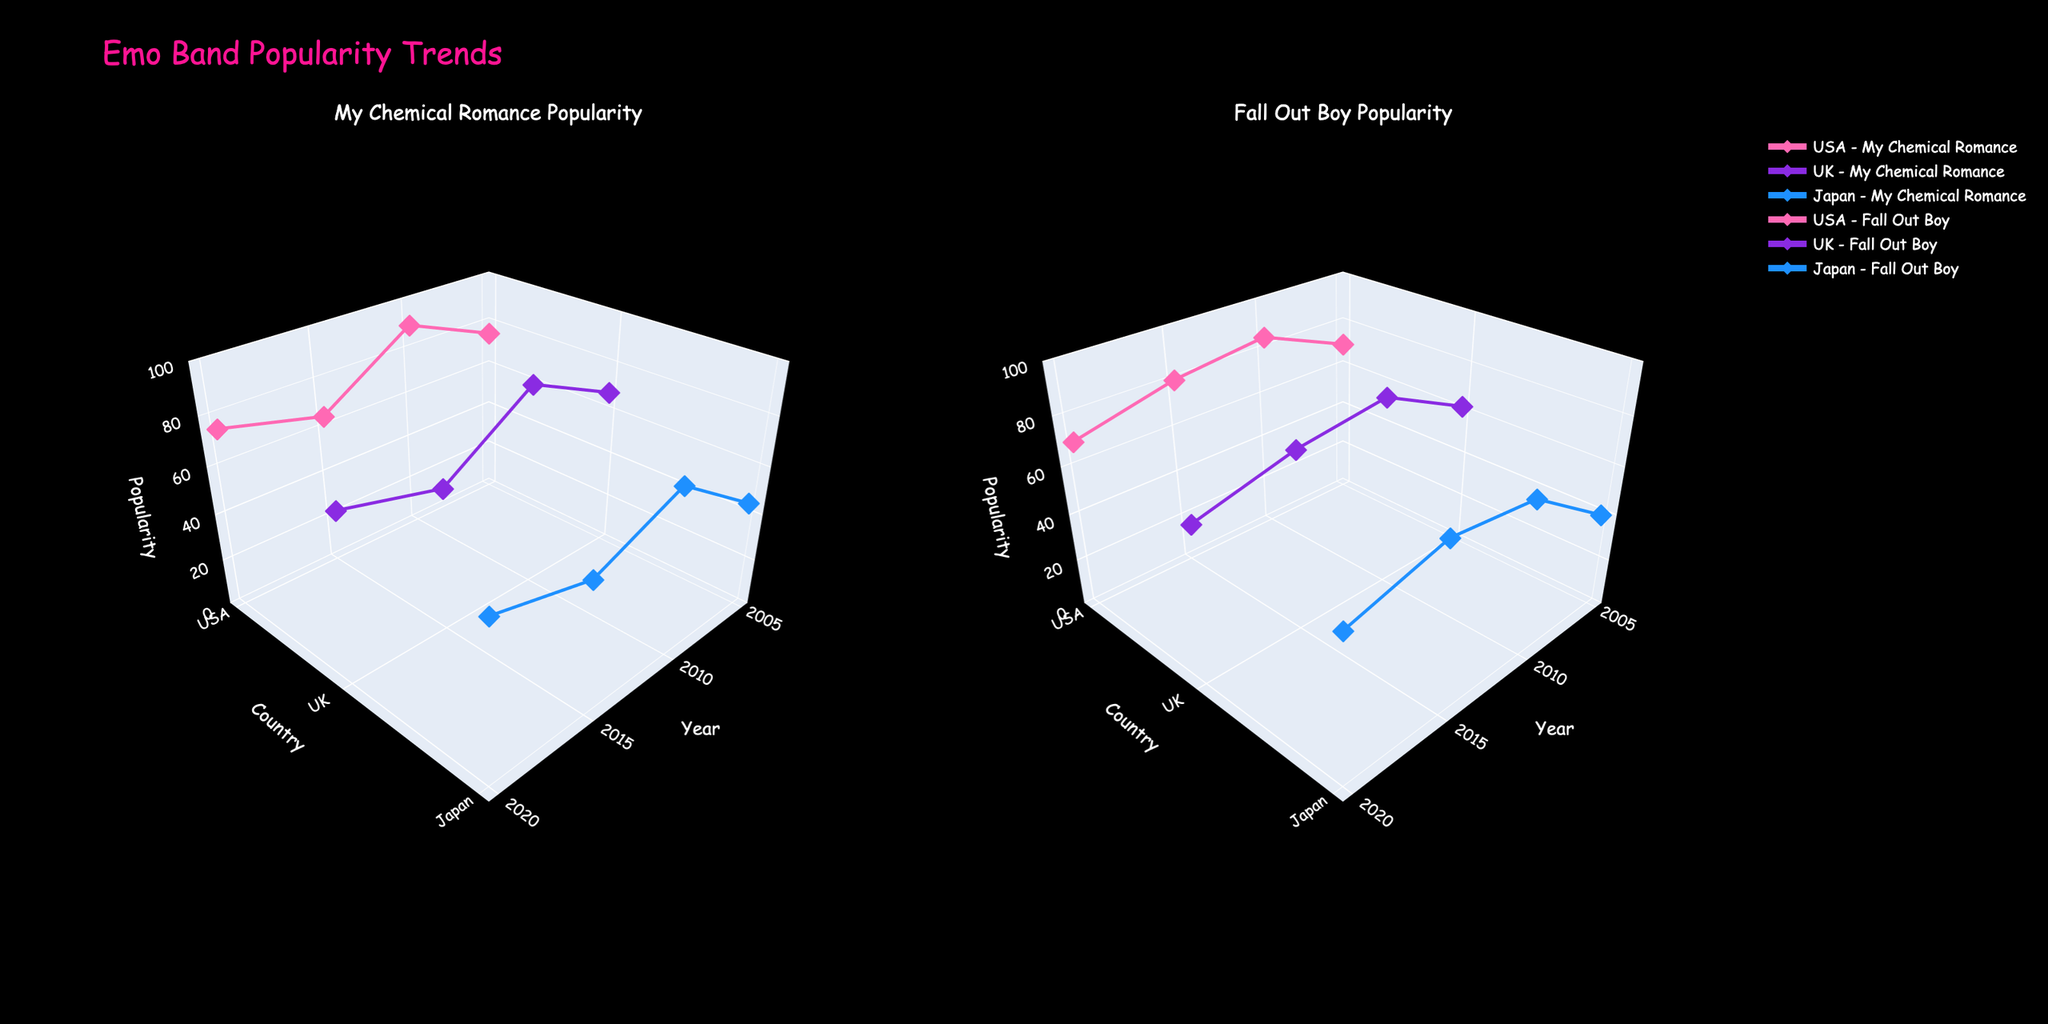What's the title of the figure? The title is usually located at the top of the figure. In this case, it is "Emo Band Popularity Trends"
Answer: Emo Band Popularity Trends What are the names of the bands analyzed in the subplots? The subplots have titles indicating the band names. The first subplot is for "My Chemical Romance," and the second subplot is for "Fall Out Boy."
Answer: My Chemical Romance and Fall Out Boy Which country had the highest popularity for My Chemical Romance in 2010? By looking at the y-axis (country) and the z-axis (popularity) for 2010 in the My Chemical Romance subplot, USA has the highest popularity value.
Answer: USA How did the popularity of Fall Out Boy in Japan change between 2005 and 2015? Locate the points for "Japan" on the z-axis of the Fall Out Boy subplot between 2005 and 2015. In 2005, the value is 40, in 2010, it's 65, and in 2015, it's 70, showing an increasing trend.
Answer: Increased Which band had a higher popularity in the USA in 2020? Check the points in the USA for both bands in 2020. For My Chemical Romance, the popularity is 75, and for Fall Out Boy, it is 70, so MCR had a higher popularity.
Answer: My Chemical Romance What is the average popularity of My Chemical Romance in the UK over all the years? Add the popularity values for MCR in the UK for all the years and divide by the number of data points: (68+85+60+70)/4 = 283/4 = 70.75
Answer: 70.75 Did Fall Out Boy's popularity in the UK ever exceed My Chemical Romance's popularity in the same country and year? Compare the popularity of Fall Out Boy and My Chemical Romance in the UK across all displayed years. Yes, in 2005 and 2015, Fall Out Boy's popularity of 62 and 75 respectively exceeded My Chemical Romance's popularity of 68 and 60.
Answer: Yes In which year did My Chemical Romance experience a decline in popularity in the USA compared to the previous year? Check the USA data points for MCR year by year. The decline is noticed when comparing 2010 (90) and 2015 (65).
Answer: 2015 